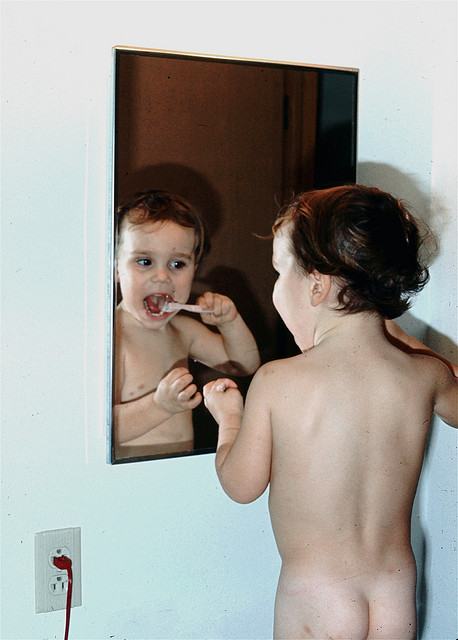<image>What is plugged in? I don't know what is plugged in. It can be a hair dryer, curling iron or red cord. What is plugged in? I don't know what is plugged in. It can be seen a hair dryer, plug, red cord, curling iron, or a cord. 